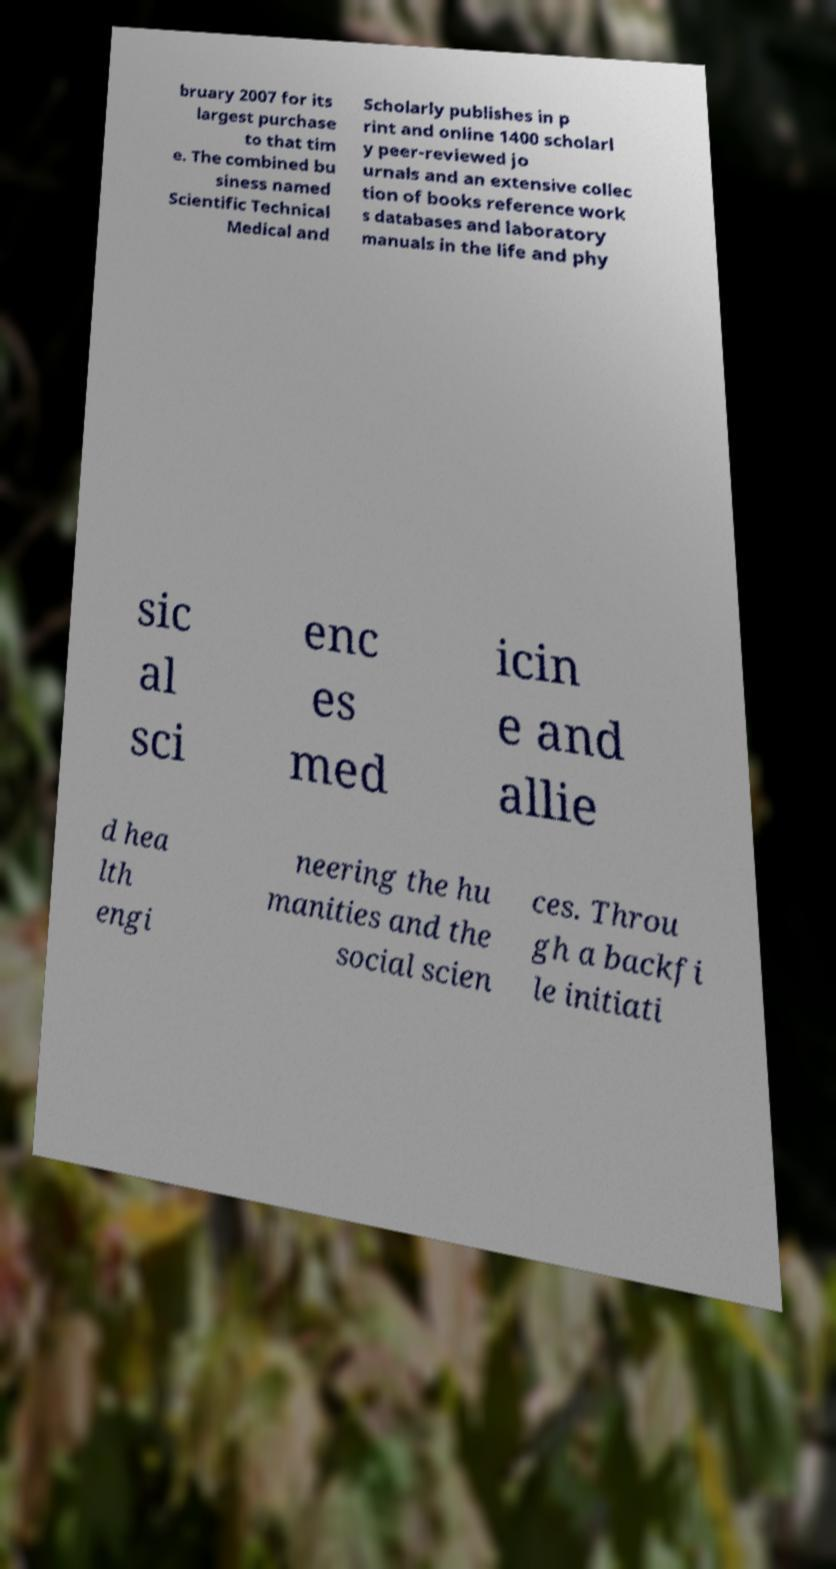What messages or text are displayed in this image? I need them in a readable, typed format. bruary 2007 for its largest purchase to that tim e. The combined bu siness named Scientific Technical Medical and Scholarly publishes in p rint and online 1400 scholarl y peer-reviewed jo urnals and an extensive collec tion of books reference work s databases and laboratory manuals in the life and phy sic al sci enc es med icin e and allie d hea lth engi neering the hu manities and the social scien ces. Throu gh a backfi le initiati 